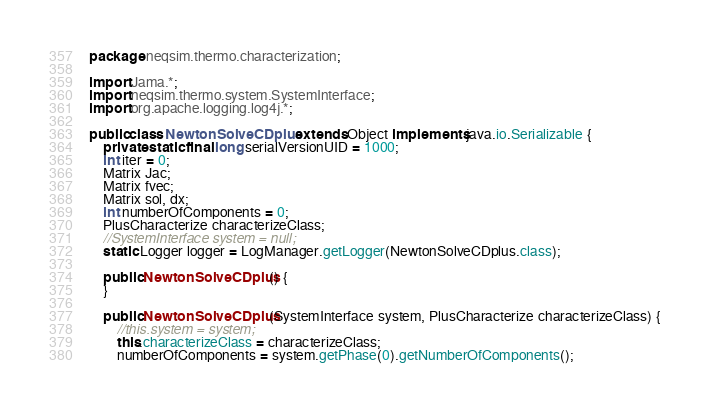<code> <loc_0><loc_0><loc_500><loc_500><_Java_>package neqsim.thermo.characterization;

import Jama.*;
import neqsim.thermo.system.SystemInterface;
import org.apache.logging.log4j.*;

public class NewtonSolveCDplus extends Object implements java.io.Serializable {
    private static final long serialVersionUID = 1000;
    int iter = 0;
    Matrix Jac;
    Matrix fvec;
    Matrix sol, dx;
    int numberOfComponents = 0;
    PlusCharacterize characterizeClass;
    //SystemInterface system = null;
    static Logger logger = LogManager.getLogger(NewtonSolveCDplus.class);

    public NewtonSolveCDplus() {
    }

    public NewtonSolveCDplus(SystemInterface system, PlusCharacterize characterizeClass) {
        //this.system = system;
        this.characterizeClass = characterizeClass;
        numberOfComponents = system.getPhase(0).getNumberOfComponents();</code> 